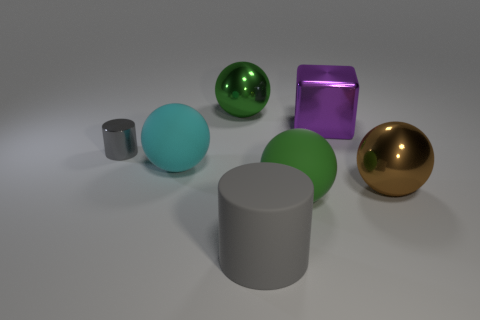Is the color of the rubber cylinder the same as the tiny metallic cylinder?
Keep it short and to the point. Yes. There is a big metallic thing to the left of the large purple metal block; is its color the same as the big matte sphere that is in front of the cyan object?
Provide a short and direct response. Yes. Is there a cylinder that has the same color as the tiny metallic object?
Provide a short and direct response. Yes. How many cylinders are made of the same material as the block?
Keep it short and to the point. 1. How many tiny objects are green rubber things or purple rubber objects?
Ensure brevity in your answer.  0. There is a big thing that is on the left side of the large gray cylinder and right of the cyan rubber object; what is its shape?
Ensure brevity in your answer.  Sphere. Does the cyan object have the same material as the purple thing?
Ensure brevity in your answer.  No. What is the color of the shiny cube that is the same size as the cyan rubber object?
Your response must be concise. Purple. There is a big ball that is both to the left of the matte cylinder and in front of the tiny cylinder; what color is it?
Your answer should be compact. Cyan. What is the size of the other rubber cylinder that is the same color as the tiny cylinder?
Your answer should be very brief. Large. 